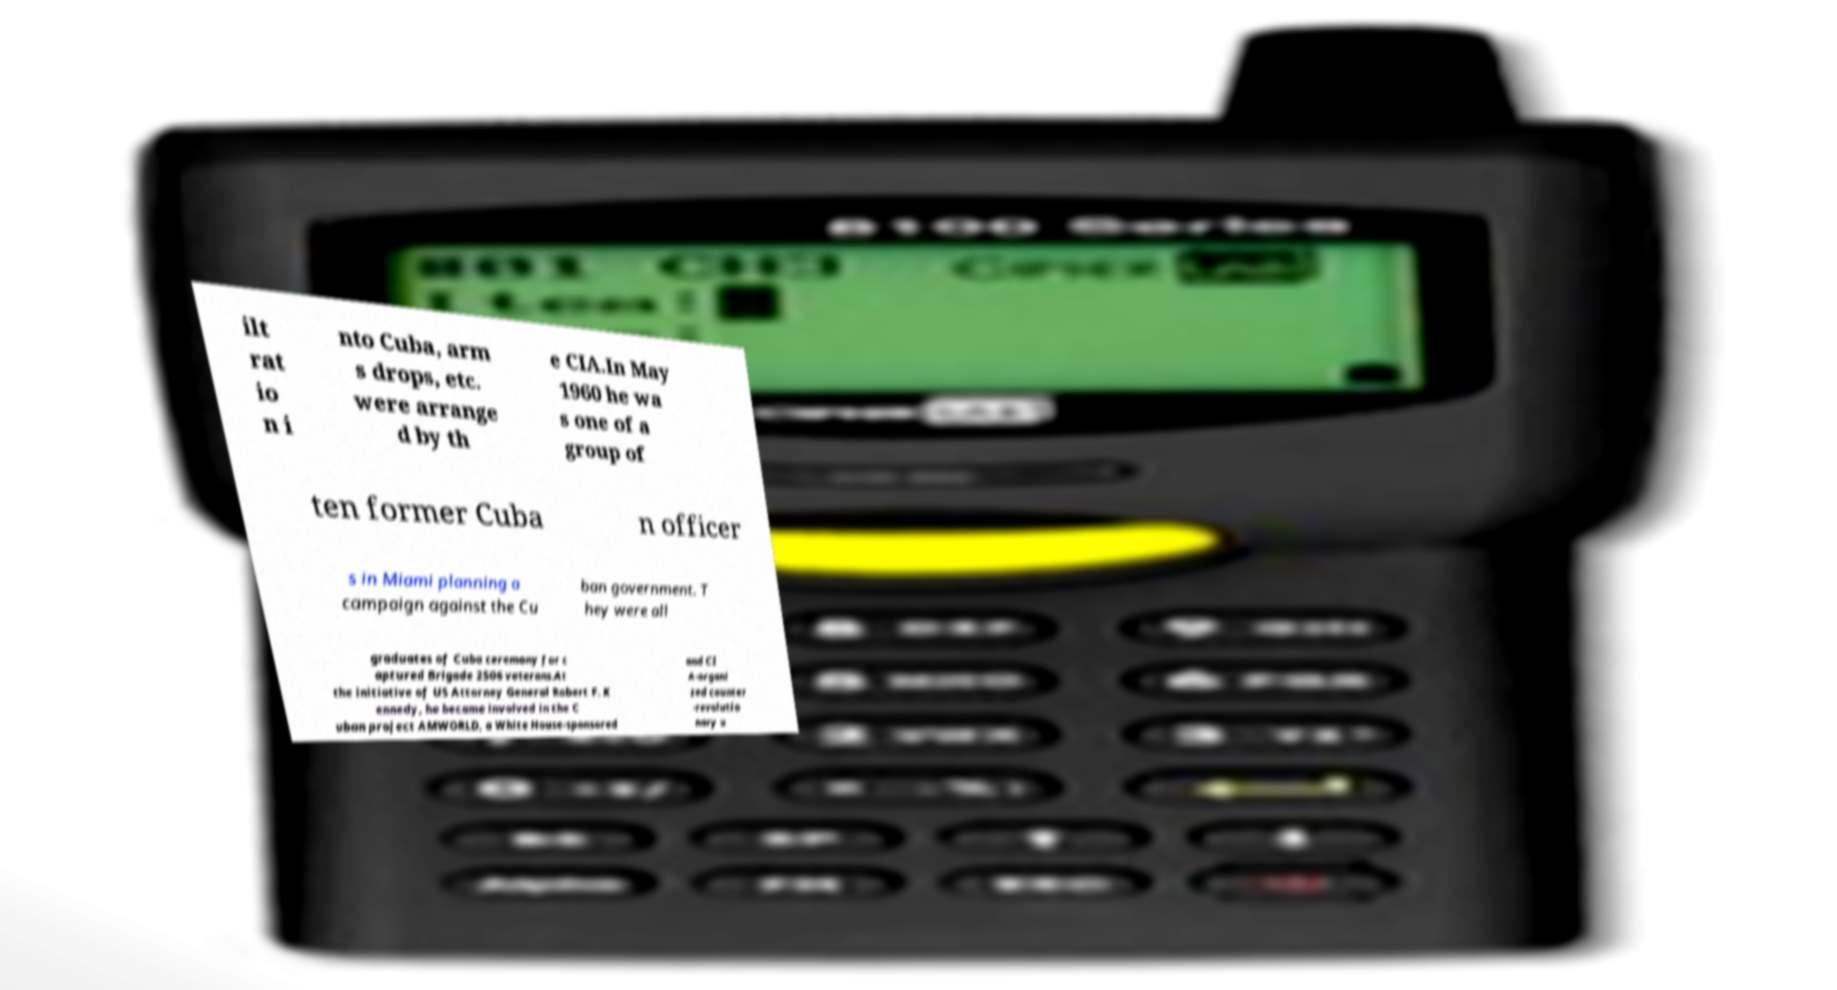What messages or text are displayed in this image? I need them in a readable, typed format. ilt rat io n i nto Cuba, arm s drops, etc. were arrange d by th e CIA.In May 1960 he wa s one of a group of ten former Cuba n officer s in Miami planning a campaign against the Cu ban government. T hey were all graduates of Cuba ceremony for c aptured Brigade 2506 veterans.At the initiative of US Attorney General Robert F. K ennedy, he became involved in the C uban project AMWORLD, a White House-sponsored and CI A-organi zed counter -revolutio nary u 